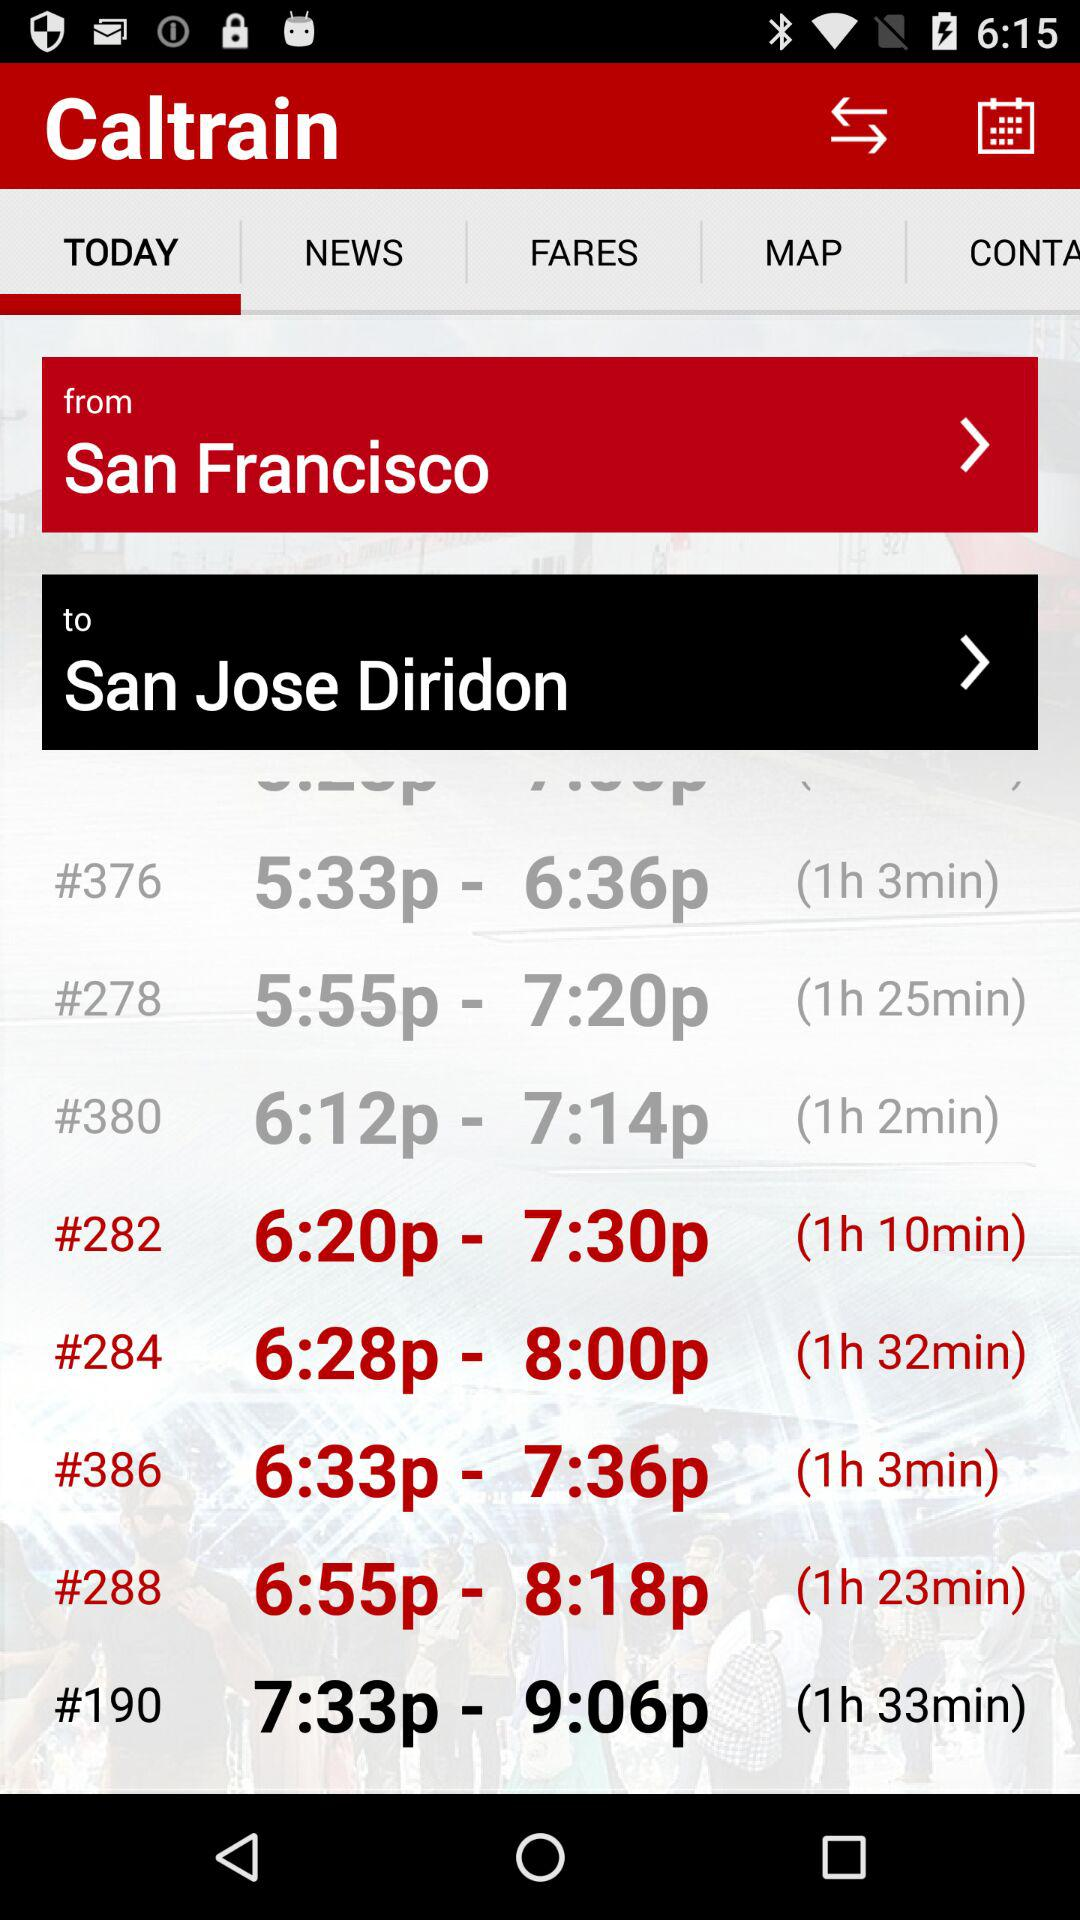What is the end location? The end location is San Jose Diridon. 